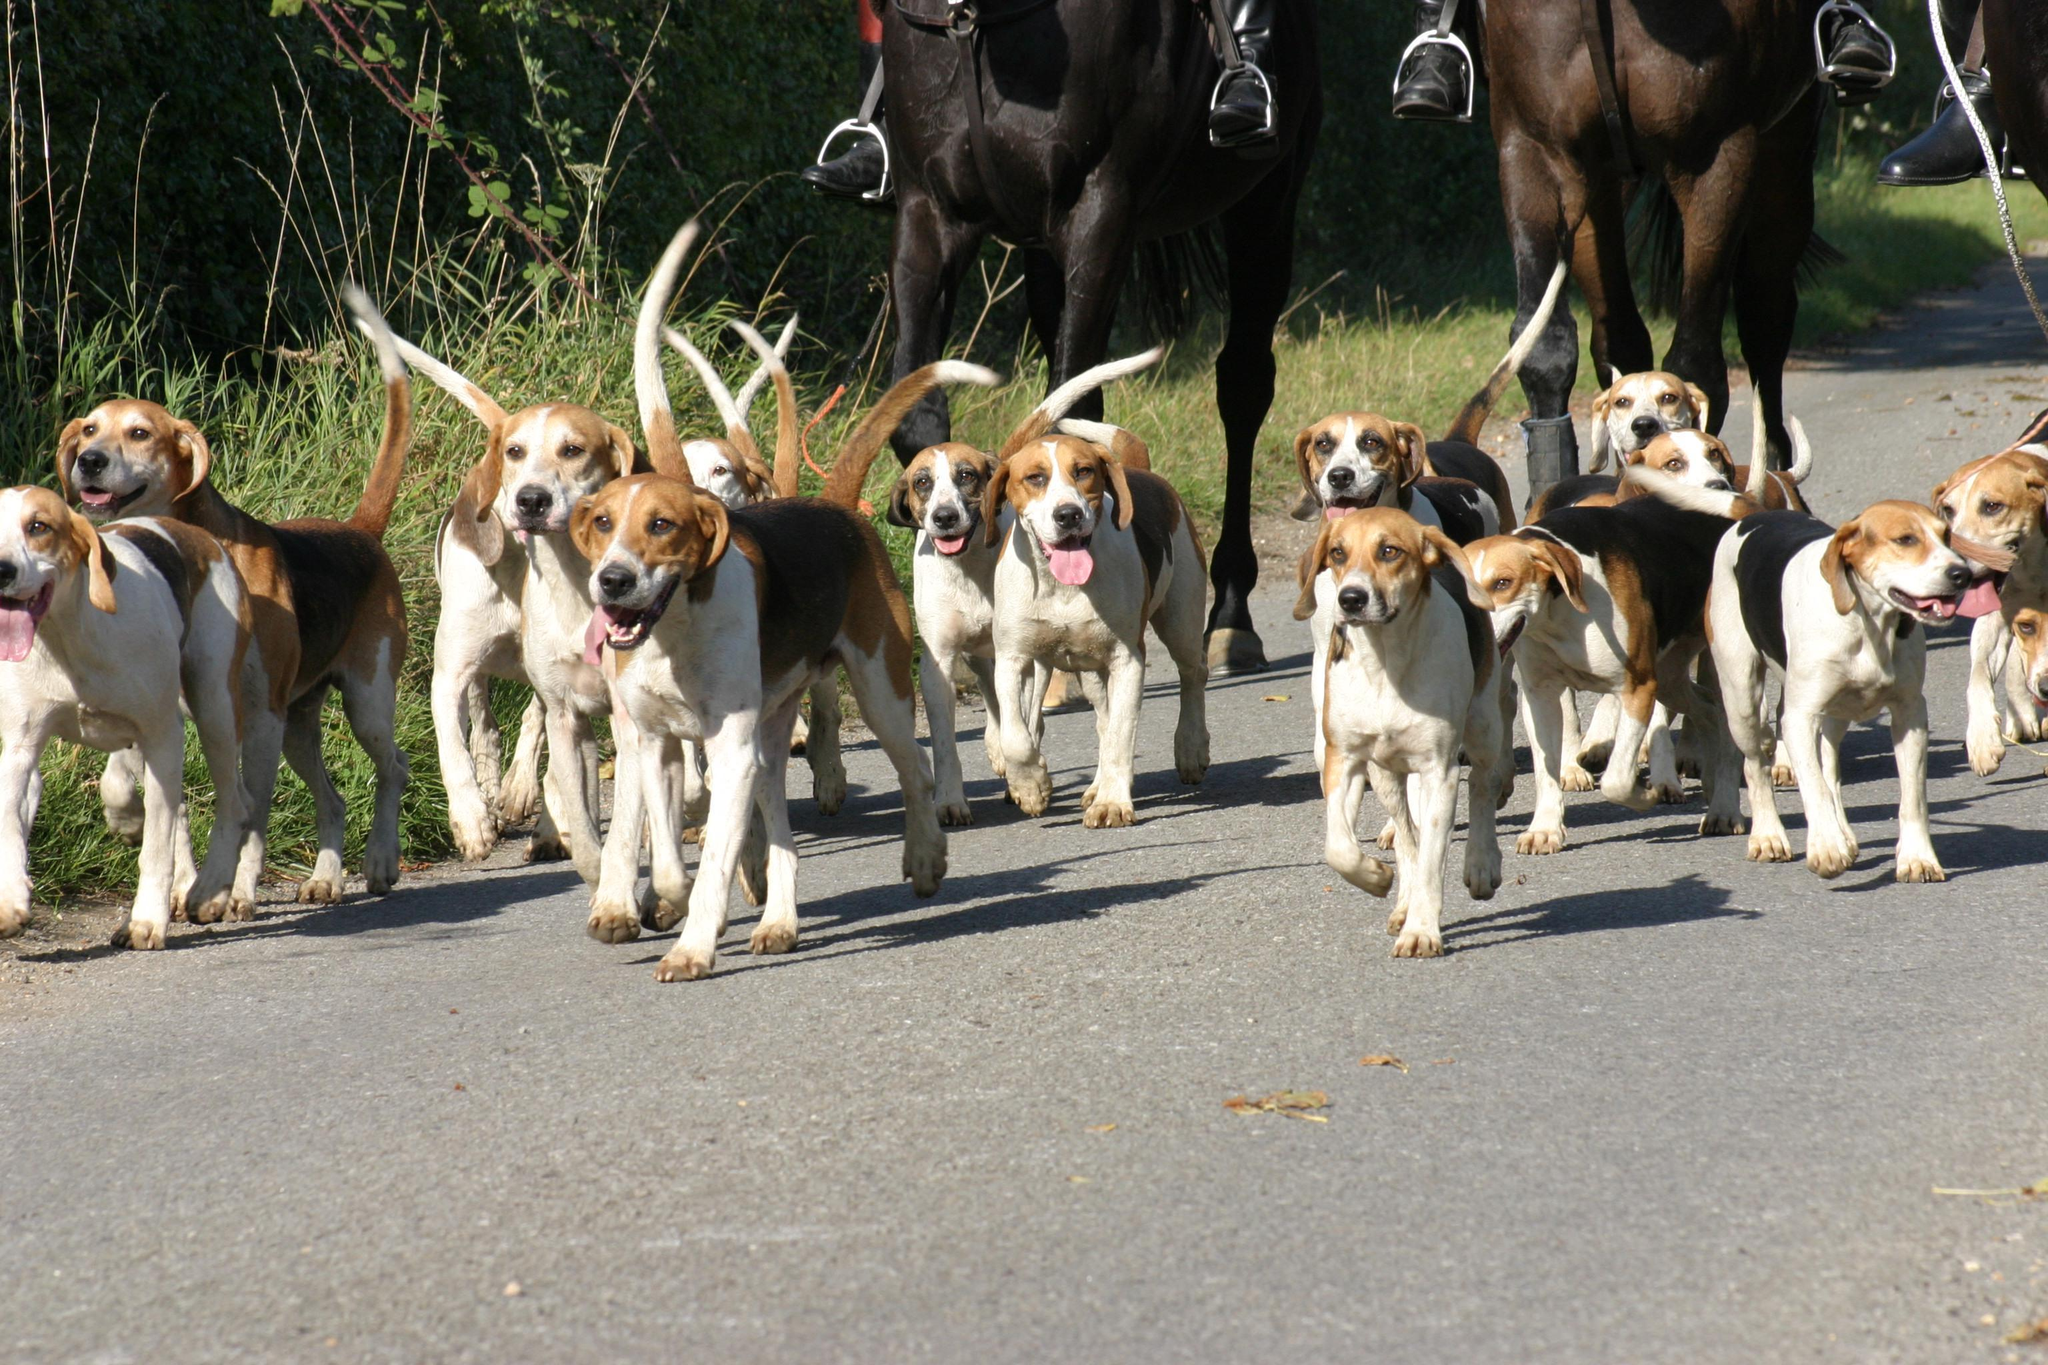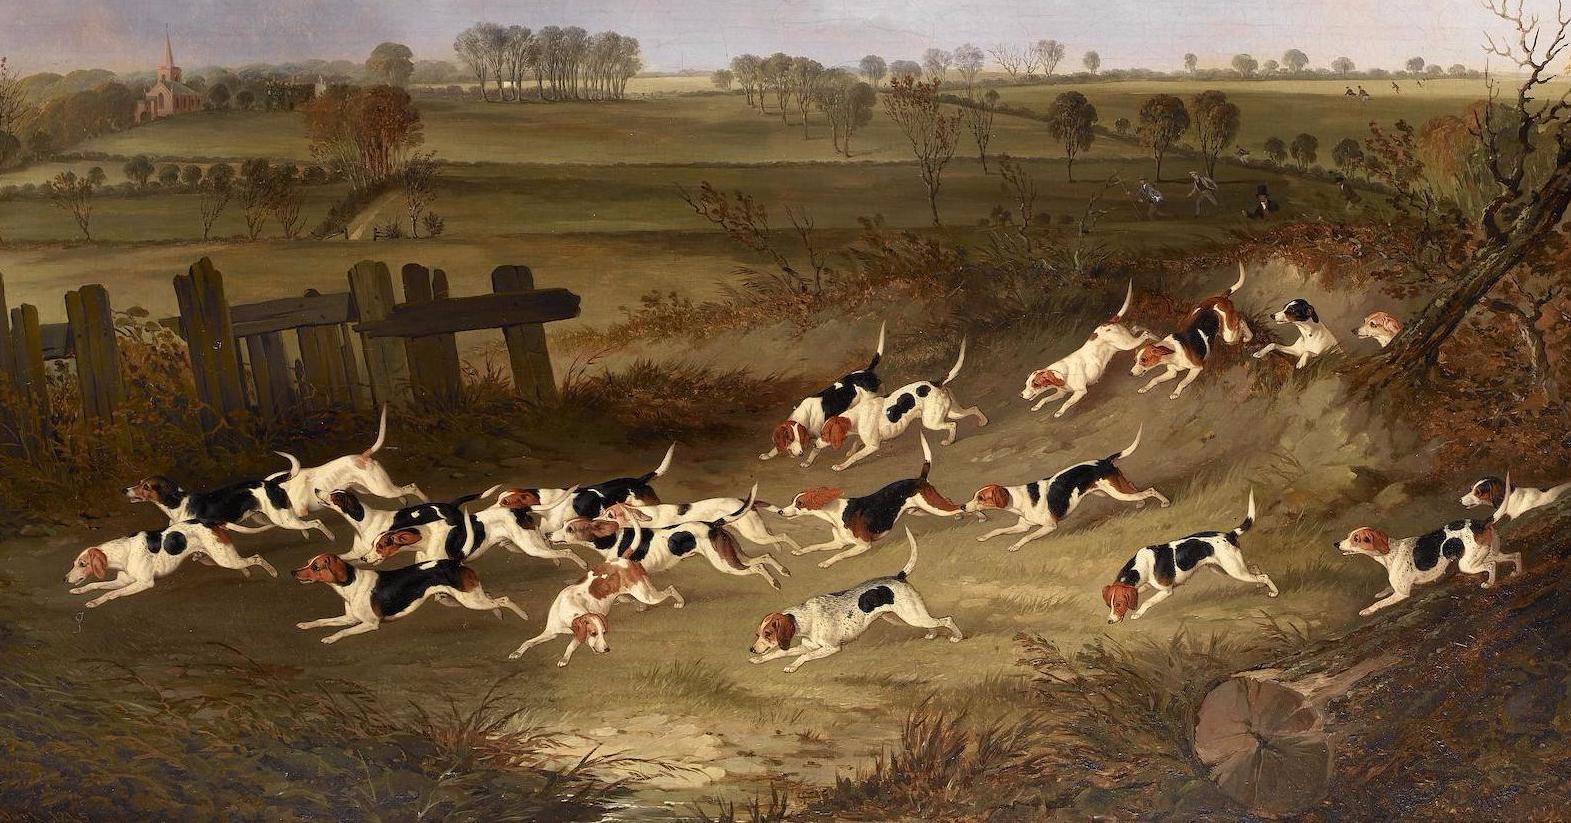The first image is the image on the left, the second image is the image on the right. For the images displayed, is the sentence "In one image, at least two people wearing hunting jackets with white breeches and black boots are on foot with a pack of hunting dogs." factually correct? Answer yes or no. No. 